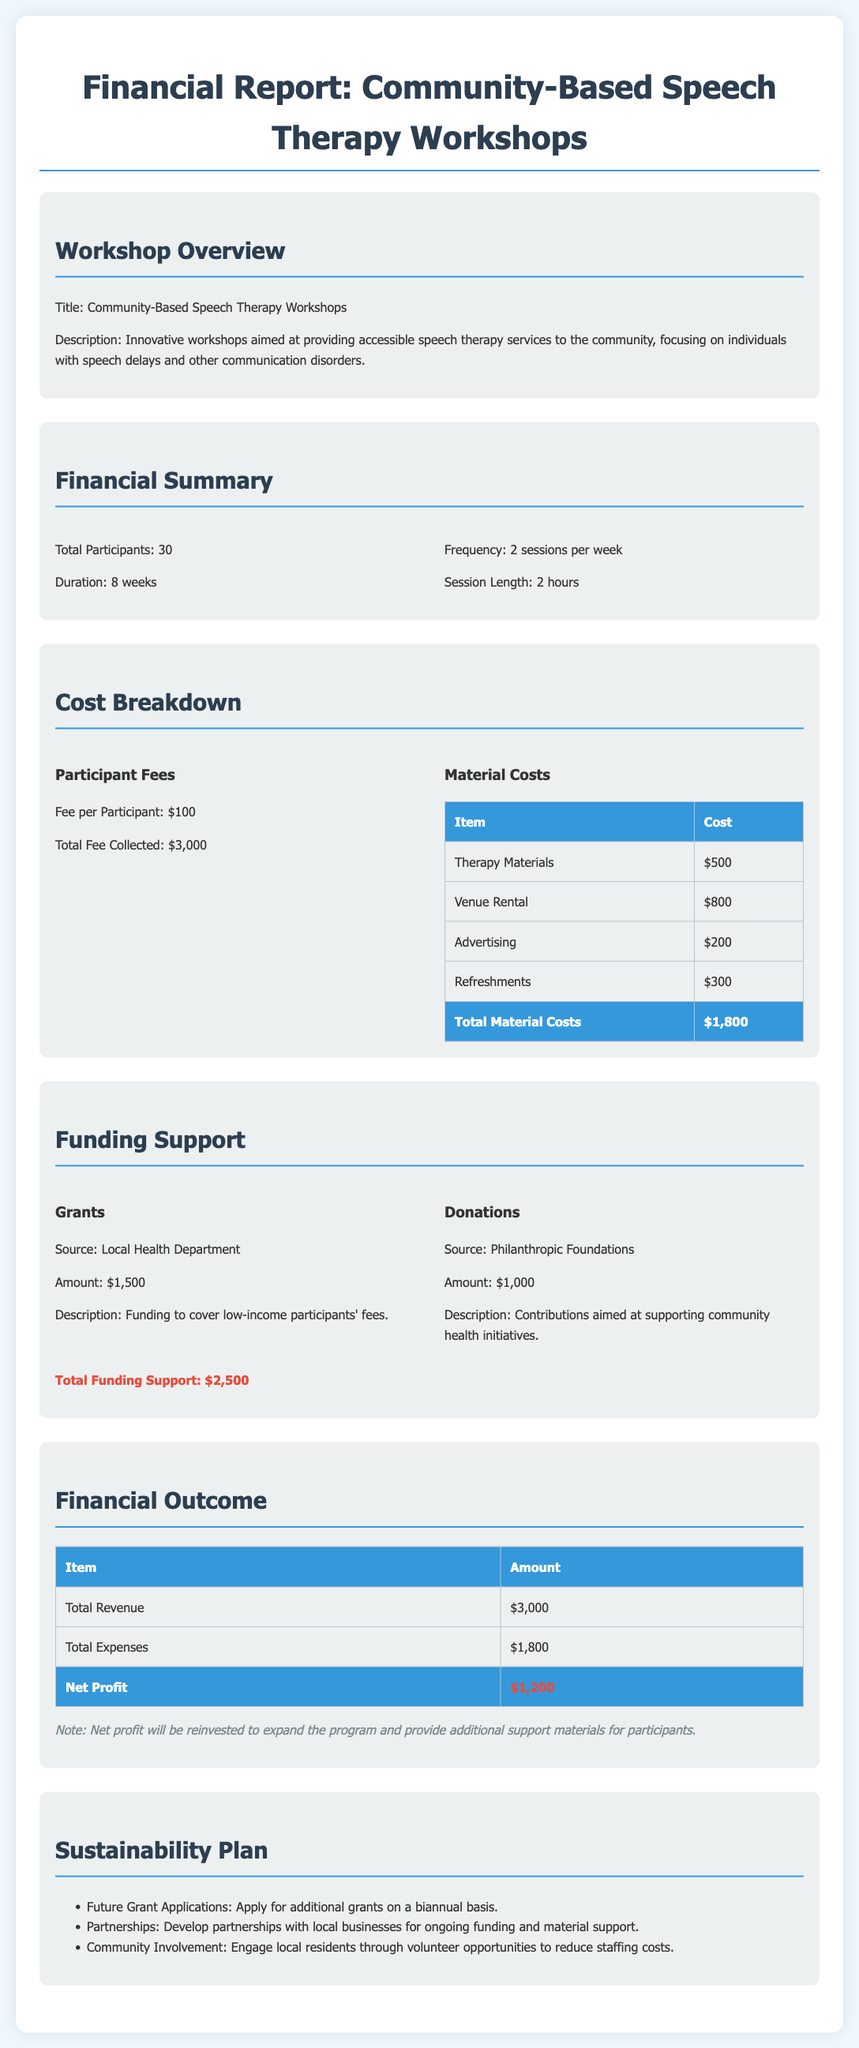What is the total number of participants? The total number of participants is explicitly stated in the financial summary section of the document.
Answer: 30 What is the total fee collected from participants? The document mentions the total fee collected from participants in the cost breakdown section.
Answer: $3,000 What is the cost of therapy materials? The specific cost of therapy materials is provided in the cost breakdown table under material costs.
Answer: $500 How much funding is received from the Local Health Department? The document specifies the amount of funding from the Local Health Department in the funding support section.
Answer: $1,500 What is the total amount of material costs? The total amount of material costs can be found in the cost breakdown section under the summary of material expenses.
Answer: $1,800 What is the net profit reported in the financial outcome section? The net profit is calculated in the financial outcome section and distinctly labeled.
Answer: $1,200 What partnerships are included in the sustainability plan? The sustainability plan suggests the development of partnerships with local businesses for ongoing support.
Answer: Local businesses What type of workshops are being discussed? The title of the workshops is explicitly stated at the beginning of the document.
Answer: Community-Based Speech Therapy Workshops How long is the duration of the workshops? The length of the workshop duration is stated in the financial summary section.
Answer: 8 weeks 